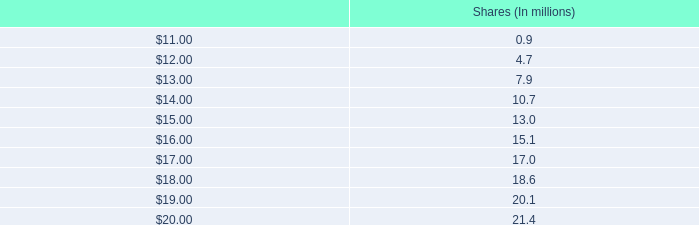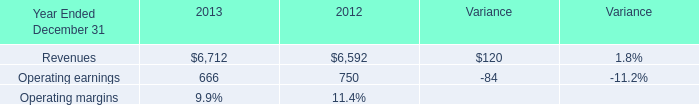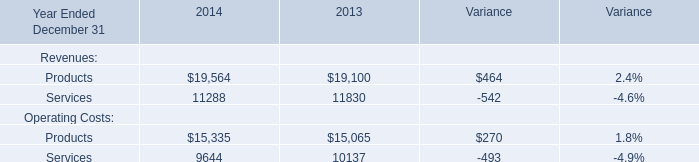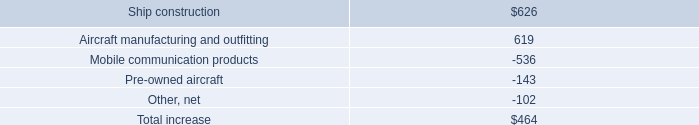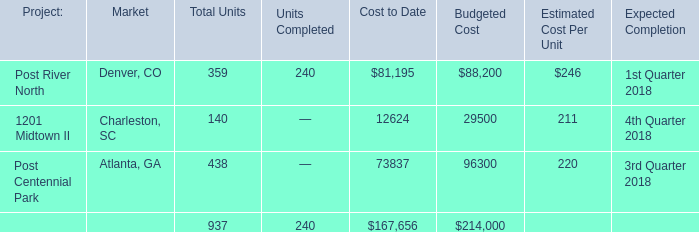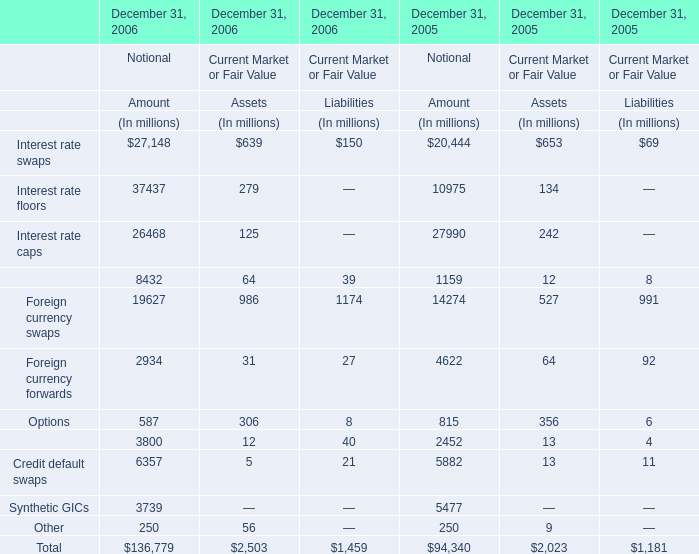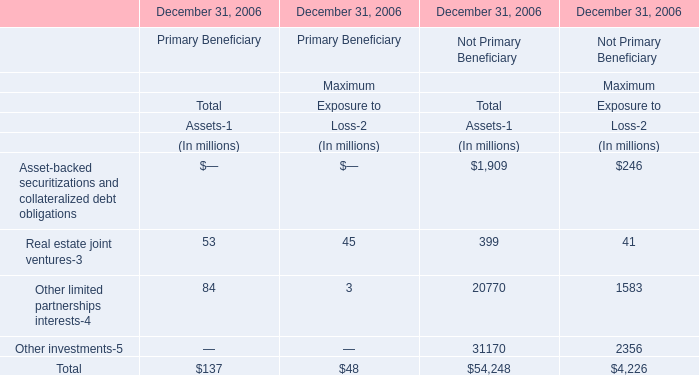what is the percentage difference in the number of shares to be issued if the stock price closes at $ 11 compared to if it closes at $ 20? 
Computations: ((21.4 - 0.9) / 0.9)
Answer: 22.77778. 